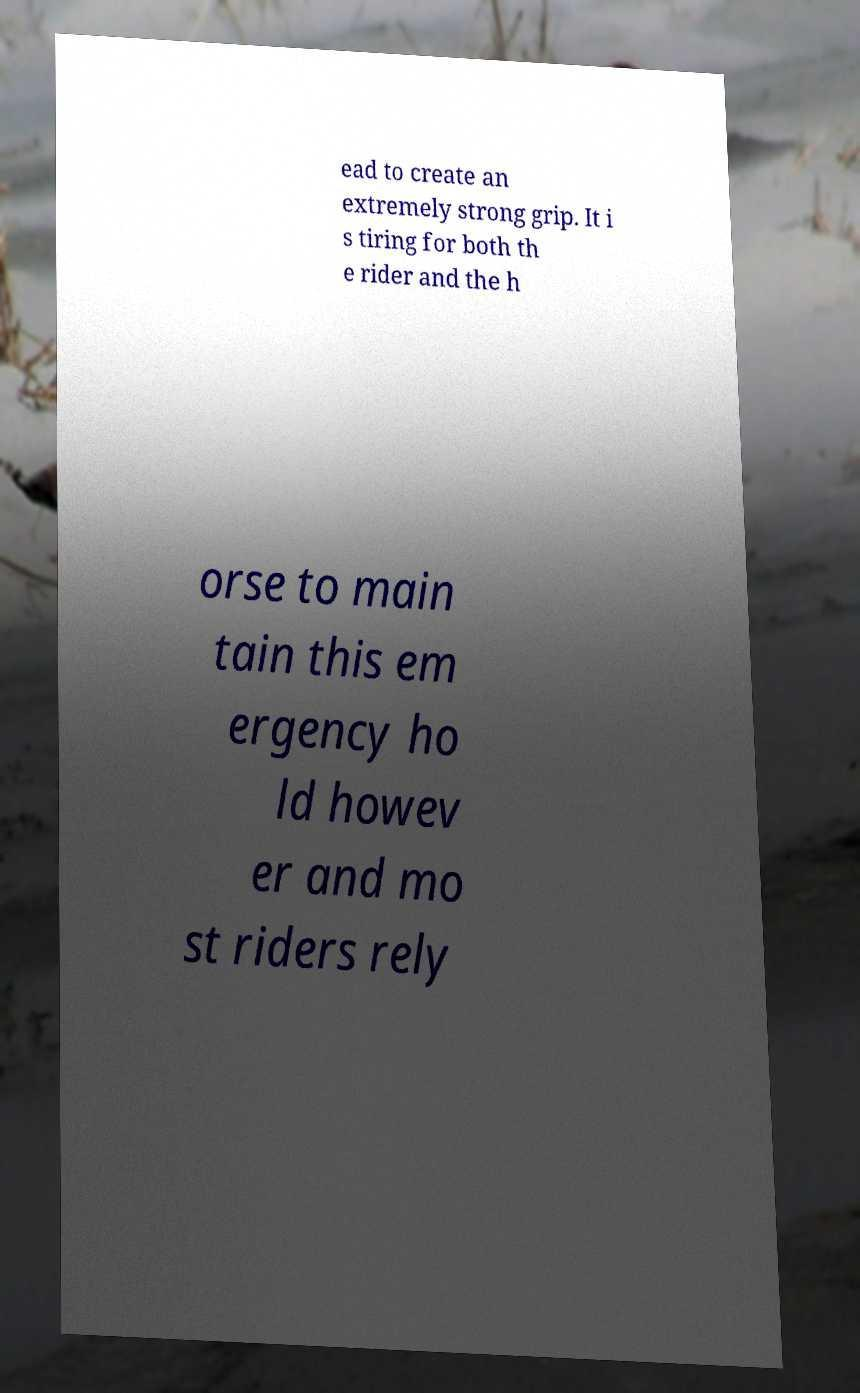For documentation purposes, I need the text within this image transcribed. Could you provide that? ead to create an extremely strong grip. It i s tiring for both th e rider and the h orse to main tain this em ergency ho ld howev er and mo st riders rely 